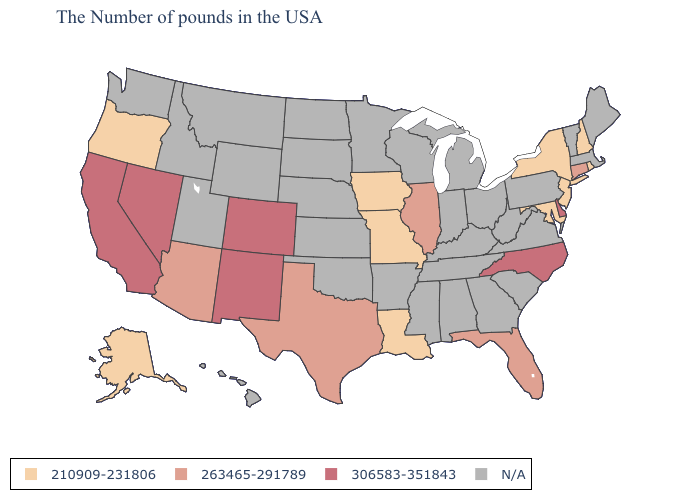Which states have the lowest value in the USA?
Answer briefly. Rhode Island, New Hampshire, New York, New Jersey, Maryland, Louisiana, Missouri, Iowa, Oregon, Alaska. What is the lowest value in the West?
Concise answer only. 210909-231806. Name the states that have a value in the range 263465-291789?
Concise answer only. Connecticut, Florida, Illinois, Texas, Arizona. How many symbols are there in the legend?
Short answer required. 4. What is the highest value in the MidWest ?
Quick response, please. 263465-291789. Which states hav the highest value in the West?
Answer briefly. Colorado, New Mexico, Nevada, California. What is the lowest value in the USA?
Concise answer only. 210909-231806. Name the states that have a value in the range 263465-291789?
Concise answer only. Connecticut, Florida, Illinois, Texas, Arizona. Does Florida have the lowest value in the South?
Give a very brief answer. No. What is the value of Alabama?
Answer briefly. N/A. What is the highest value in the South ?
Concise answer only. 306583-351843. Name the states that have a value in the range 306583-351843?
Quick response, please. Delaware, North Carolina, Colorado, New Mexico, Nevada, California. Does Florida have the highest value in the USA?
Concise answer only. No. 